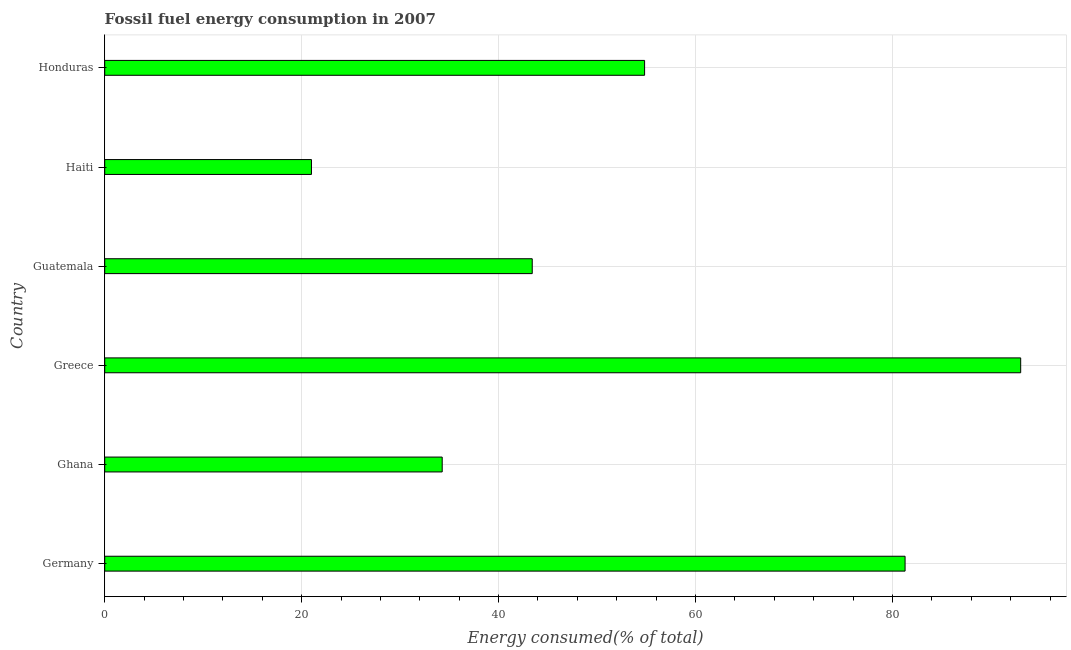Does the graph contain any zero values?
Your answer should be compact. No. What is the title of the graph?
Provide a succinct answer. Fossil fuel energy consumption in 2007. What is the label or title of the X-axis?
Offer a terse response. Energy consumed(% of total). What is the fossil fuel energy consumption in Guatemala?
Your answer should be compact. 43.42. Across all countries, what is the maximum fossil fuel energy consumption?
Your response must be concise. 93.02. Across all countries, what is the minimum fossil fuel energy consumption?
Offer a terse response. 21. In which country was the fossil fuel energy consumption minimum?
Your answer should be very brief. Haiti. What is the sum of the fossil fuel energy consumption?
Ensure brevity in your answer.  327.81. What is the difference between the fossil fuel energy consumption in Greece and Honduras?
Offer a terse response. 38.19. What is the average fossil fuel energy consumption per country?
Ensure brevity in your answer.  54.63. What is the median fossil fuel energy consumption?
Provide a succinct answer. 49.12. What is the ratio of the fossil fuel energy consumption in Ghana to that in Honduras?
Offer a terse response. 0.62. Is the fossil fuel energy consumption in Ghana less than that in Guatemala?
Your response must be concise. Yes. Is the difference between the fossil fuel energy consumption in Ghana and Honduras greater than the difference between any two countries?
Make the answer very short. No. What is the difference between the highest and the second highest fossil fuel energy consumption?
Provide a short and direct response. 11.74. What is the difference between the highest and the lowest fossil fuel energy consumption?
Your response must be concise. 72.03. In how many countries, is the fossil fuel energy consumption greater than the average fossil fuel energy consumption taken over all countries?
Make the answer very short. 3. How many bars are there?
Provide a short and direct response. 6. What is the difference between two consecutive major ticks on the X-axis?
Your answer should be very brief. 20. What is the Energy consumed(% of total) in Germany?
Keep it short and to the point. 81.28. What is the Energy consumed(% of total) of Ghana?
Keep it short and to the point. 34.27. What is the Energy consumed(% of total) in Greece?
Ensure brevity in your answer.  93.02. What is the Energy consumed(% of total) in Guatemala?
Provide a succinct answer. 43.42. What is the Energy consumed(% of total) in Haiti?
Your response must be concise. 21. What is the Energy consumed(% of total) in Honduras?
Provide a succinct answer. 54.83. What is the difference between the Energy consumed(% of total) in Germany and Ghana?
Your answer should be very brief. 47.01. What is the difference between the Energy consumed(% of total) in Germany and Greece?
Keep it short and to the point. -11.74. What is the difference between the Energy consumed(% of total) in Germany and Guatemala?
Keep it short and to the point. 37.86. What is the difference between the Energy consumed(% of total) in Germany and Haiti?
Offer a terse response. 60.28. What is the difference between the Energy consumed(% of total) in Germany and Honduras?
Ensure brevity in your answer.  26.45. What is the difference between the Energy consumed(% of total) in Ghana and Greece?
Ensure brevity in your answer.  -58.75. What is the difference between the Energy consumed(% of total) in Ghana and Guatemala?
Your answer should be compact. -9.14. What is the difference between the Energy consumed(% of total) in Ghana and Haiti?
Provide a succinct answer. 13.28. What is the difference between the Energy consumed(% of total) in Ghana and Honduras?
Ensure brevity in your answer.  -20.55. What is the difference between the Energy consumed(% of total) in Greece and Guatemala?
Make the answer very short. 49.6. What is the difference between the Energy consumed(% of total) in Greece and Haiti?
Give a very brief answer. 72.03. What is the difference between the Energy consumed(% of total) in Greece and Honduras?
Keep it short and to the point. 38.19. What is the difference between the Energy consumed(% of total) in Guatemala and Haiti?
Provide a short and direct response. 22.42. What is the difference between the Energy consumed(% of total) in Guatemala and Honduras?
Your answer should be compact. -11.41. What is the difference between the Energy consumed(% of total) in Haiti and Honduras?
Offer a very short reply. -33.83. What is the ratio of the Energy consumed(% of total) in Germany to that in Ghana?
Your answer should be compact. 2.37. What is the ratio of the Energy consumed(% of total) in Germany to that in Greece?
Offer a terse response. 0.87. What is the ratio of the Energy consumed(% of total) in Germany to that in Guatemala?
Your answer should be compact. 1.87. What is the ratio of the Energy consumed(% of total) in Germany to that in Haiti?
Make the answer very short. 3.87. What is the ratio of the Energy consumed(% of total) in Germany to that in Honduras?
Your response must be concise. 1.48. What is the ratio of the Energy consumed(% of total) in Ghana to that in Greece?
Keep it short and to the point. 0.37. What is the ratio of the Energy consumed(% of total) in Ghana to that in Guatemala?
Your answer should be compact. 0.79. What is the ratio of the Energy consumed(% of total) in Ghana to that in Haiti?
Offer a terse response. 1.63. What is the ratio of the Energy consumed(% of total) in Ghana to that in Honduras?
Offer a very short reply. 0.62. What is the ratio of the Energy consumed(% of total) in Greece to that in Guatemala?
Make the answer very short. 2.14. What is the ratio of the Energy consumed(% of total) in Greece to that in Haiti?
Your answer should be very brief. 4.43. What is the ratio of the Energy consumed(% of total) in Greece to that in Honduras?
Your response must be concise. 1.7. What is the ratio of the Energy consumed(% of total) in Guatemala to that in Haiti?
Your answer should be compact. 2.07. What is the ratio of the Energy consumed(% of total) in Guatemala to that in Honduras?
Make the answer very short. 0.79. What is the ratio of the Energy consumed(% of total) in Haiti to that in Honduras?
Give a very brief answer. 0.38. 